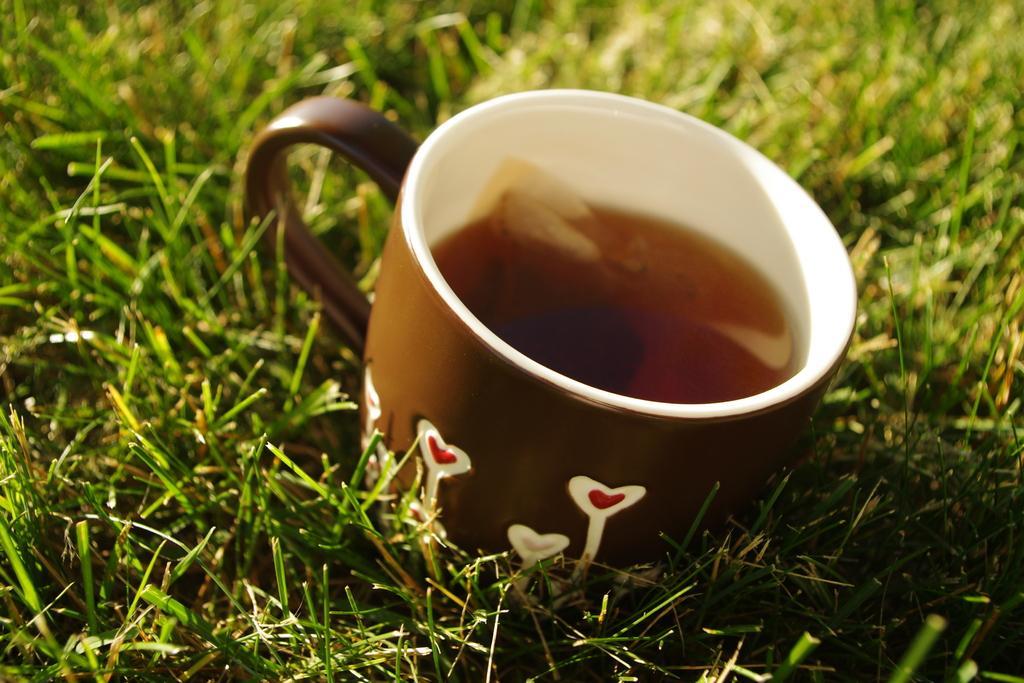Could you give a brief overview of what you see in this image? In the middle of the image, there is a brown color cup having a liquid in it on the grass on the ground. And the background is blurred. 